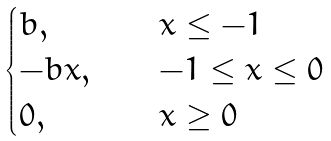<formula> <loc_0><loc_0><loc_500><loc_500>\begin{cases} b , \quad & x \leq - 1 \\ - b x , \quad & - 1 \leq x \leq 0 \\ 0 , \quad & x \geq 0 \\ \end{cases}</formula> 